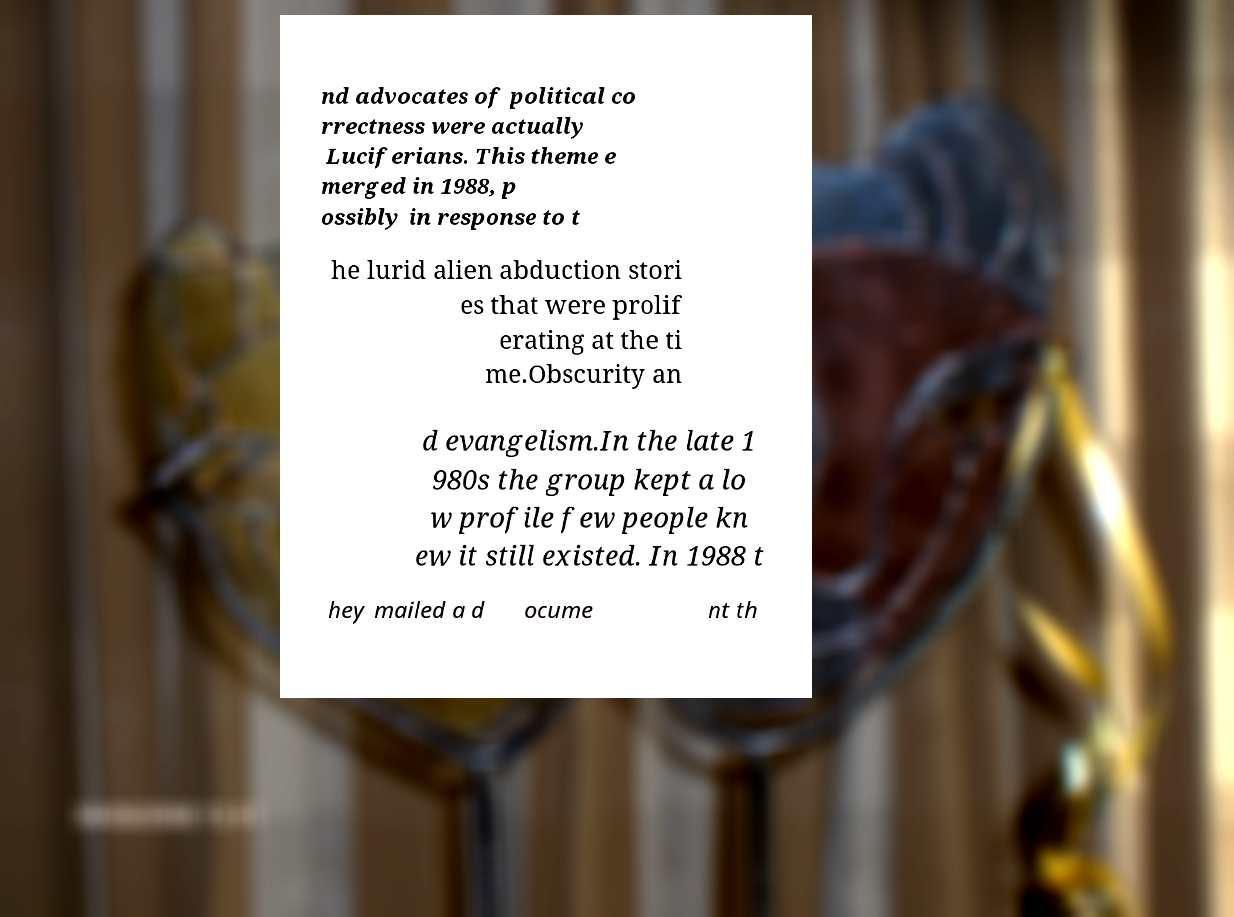Could you extract and type out the text from this image? nd advocates of political co rrectness were actually Luciferians. This theme e merged in 1988, p ossibly in response to t he lurid alien abduction stori es that were prolif erating at the ti me.Obscurity an d evangelism.In the late 1 980s the group kept a lo w profile few people kn ew it still existed. In 1988 t hey mailed a d ocume nt th 